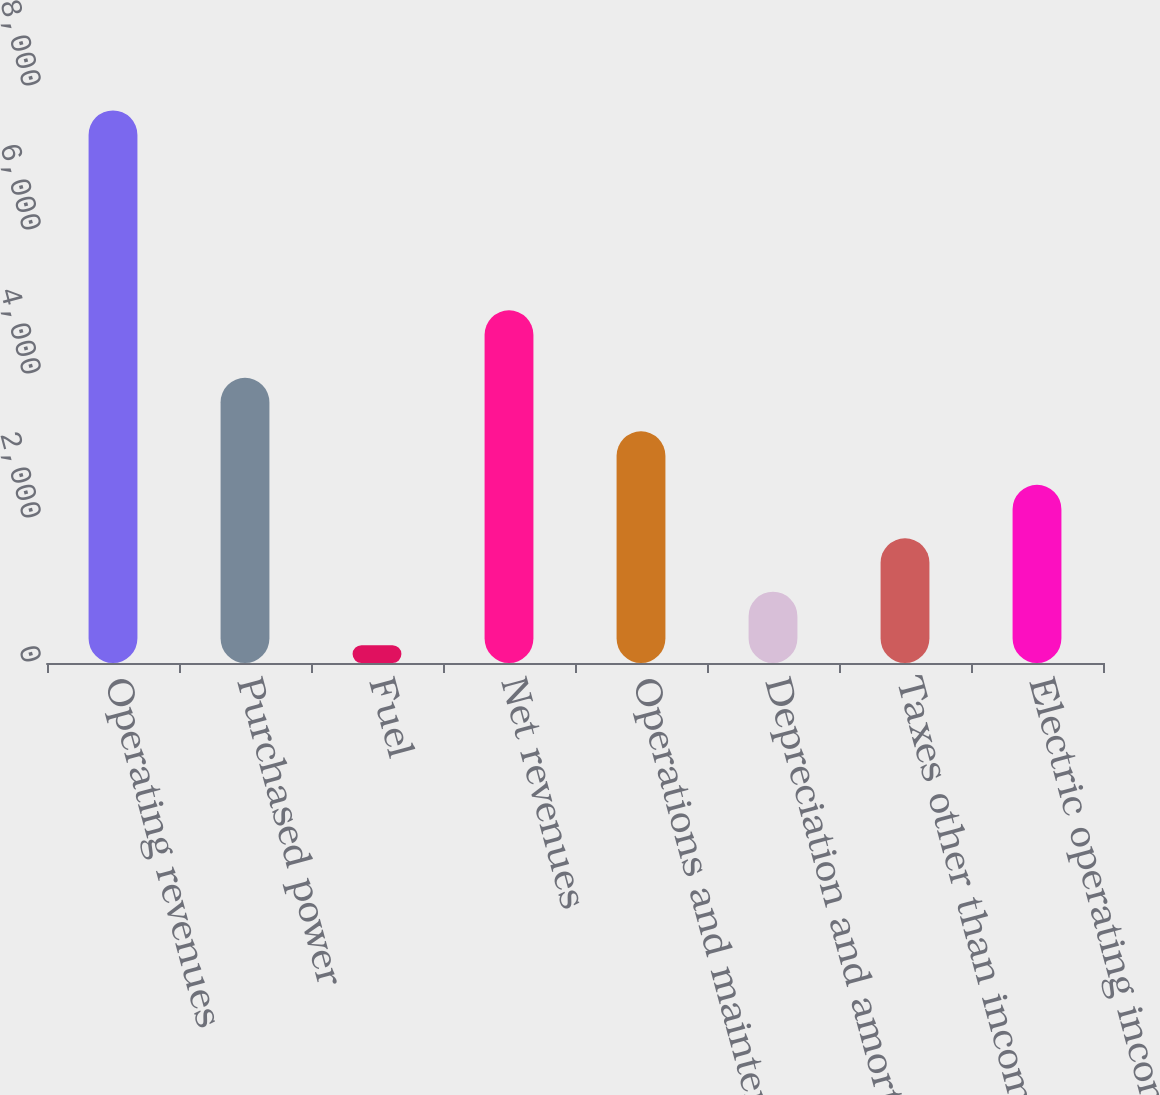Convert chart to OTSL. <chart><loc_0><loc_0><loc_500><loc_500><bar_chart><fcel>Operating revenues<fcel>Purchased power<fcel>Fuel<fcel>Net revenues<fcel>Operations and maintenance<fcel>Depreciation and amortization<fcel>Taxes other than income taxes<fcel>Electric operating income<nl><fcel>7674<fcel>3960.5<fcel>247<fcel>4898<fcel>3217.8<fcel>989.7<fcel>1732.4<fcel>2475.1<nl></chart> 